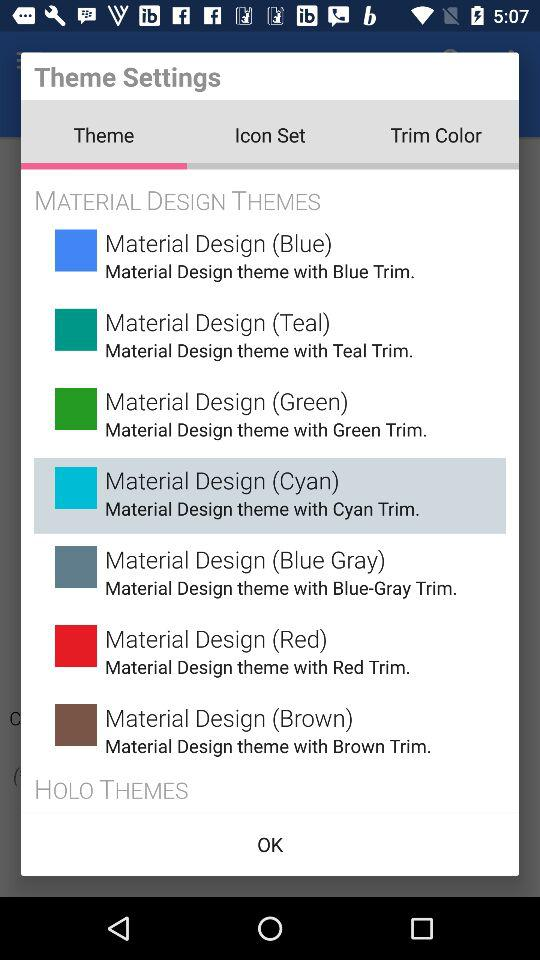Which tab is selected? The selected tab is "Theme". 